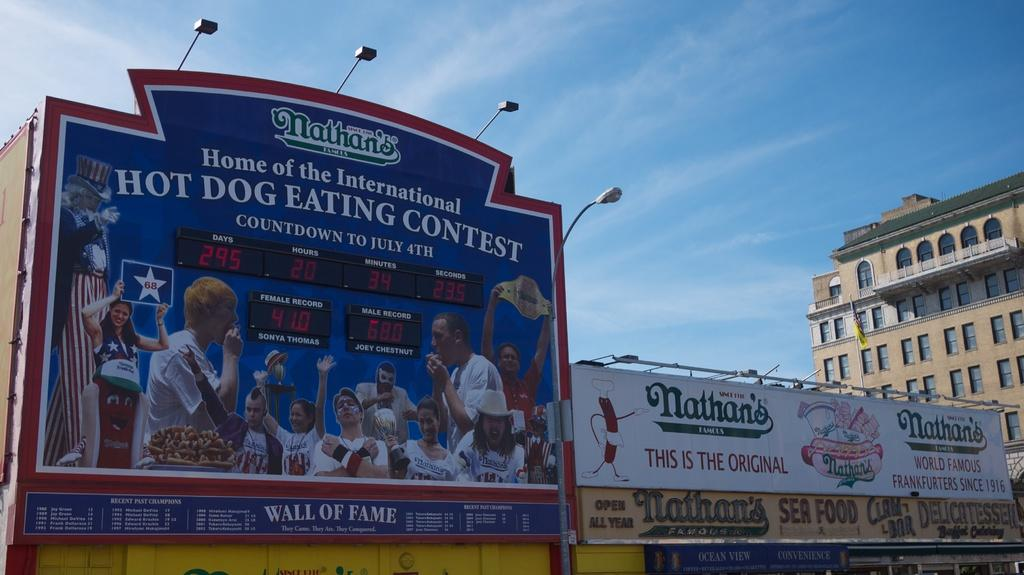Provide a one-sentence caption for the provided image. The sign is advertising the Nathan's hot dog eating contest. 